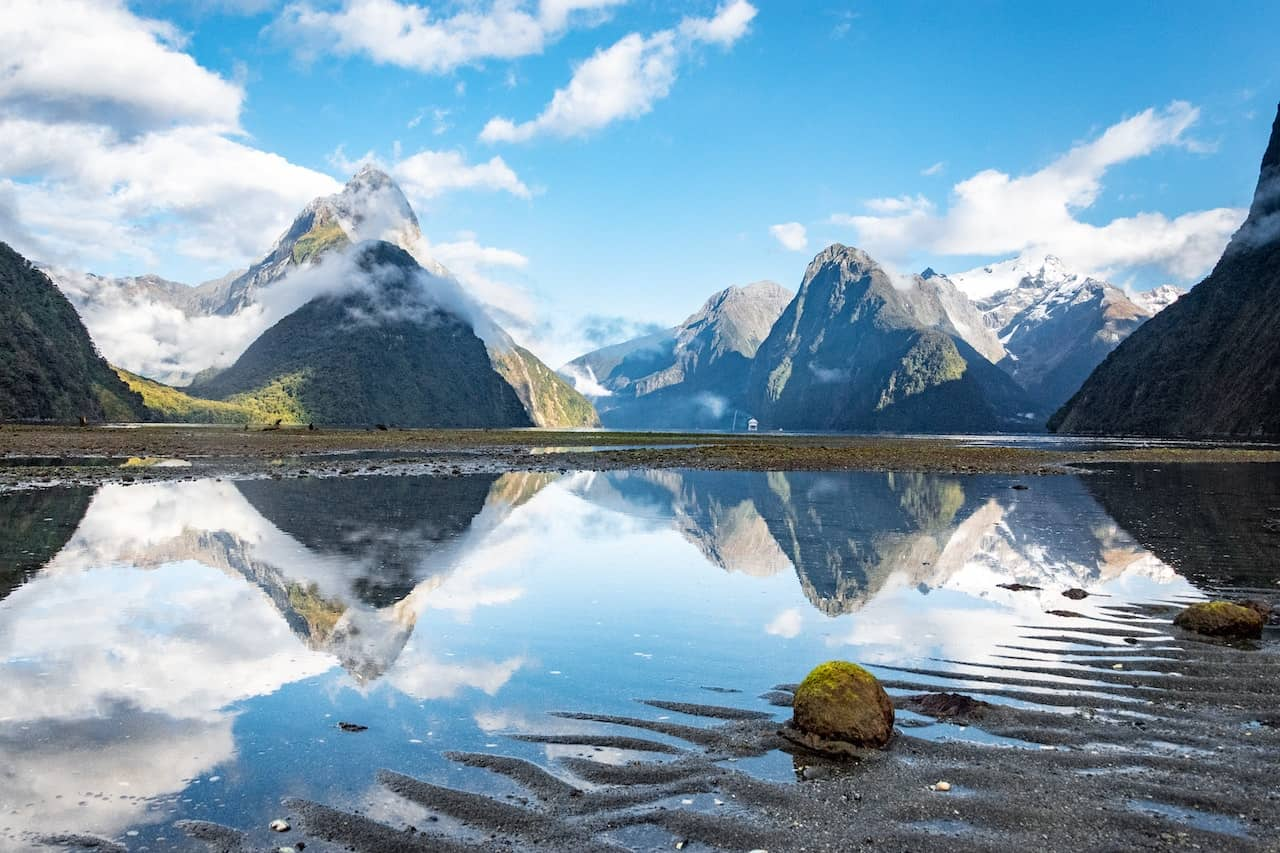Can you tell me more about the wildlife one might encounter in this region? Milford Sound is home to a rich array of wildlife. Visitors might see species such as the Fiordland penguin, seals lounging on the rocks, and dolphins playing in the water. The surrounding forests are also a haven for various bird species, including the rare Fiordland crested penguin and the kea, a native parrot known for its intelligence and curiosity. 